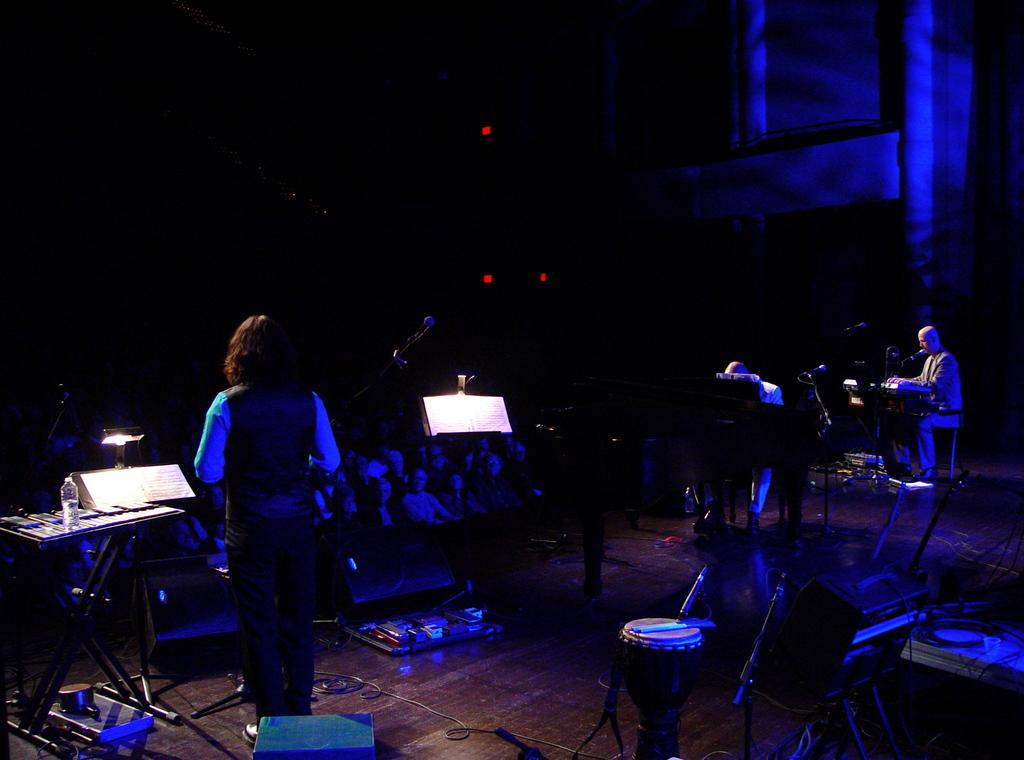In one or two sentences, can you explain what this image depicts? In the picture I can see the music instruments, tables, bottles, lights and people. 